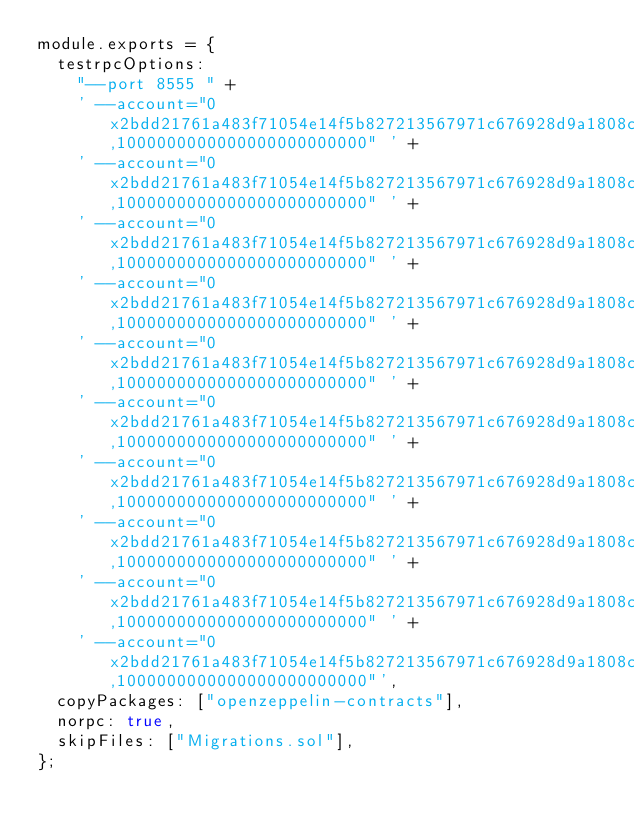<code> <loc_0><loc_0><loc_500><loc_500><_JavaScript_>module.exports = {
  testrpcOptions:
    "--port 8555 " +
    ' --account="0x2bdd21761a483f71054e14f5b827213567971c676928d9a1808cbfa4b7501200,1000000000000000000000000" ' +
    ' --account="0x2bdd21761a483f71054e14f5b827213567971c676928d9a1808cbfa4b7501201,1000000000000000000000000" ' +
    ' --account="0x2bdd21761a483f71054e14f5b827213567971c676928d9a1808cbfa4b7501202,1000000000000000000000000" ' +
    ' --account="0x2bdd21761a483f71054e14f5b827213567971c676928d9a1808cbfa4b7501203,1000000000000000000000000" ' +
    ' --account="0x2bdd21761a483f71054e14f5b827213567971c676928d9a1808cbfa4b7501204,1000000000000000000000000" ' +
    ' --account="0x2bdd21761a483f71054e14f5b827213567971c676928d9a1808cbfa4b7501205,1000000000000000000000000" ' +
    ' --account="0x2bdd21761a483f71054e14f5b827213567971c676928d9a1808cbfa4b7501206,1000000000000000000000000" ' +
    ' --account="0x2bdd21761a483f71054e14f5b827213567971c676928d9a1808cbfa4b7501207,1000000000000000000000000" ' +
    ' --account="0x2bdd21761a483f71054e14f5b827213567971c676928d9a1808cbfa4b7501208,1000000000000000000000000" ' +
    ' --account="0x2bdd21761a483f71054e14f5b827213567971c676928d9a1808cbfa4b7501209,1000000000000000000000000"',
  copyPackages: ["openzeppelin-contracts"],
  norpc: true,
  skipFiles: ["Migrations.sol"],
};
</code> 